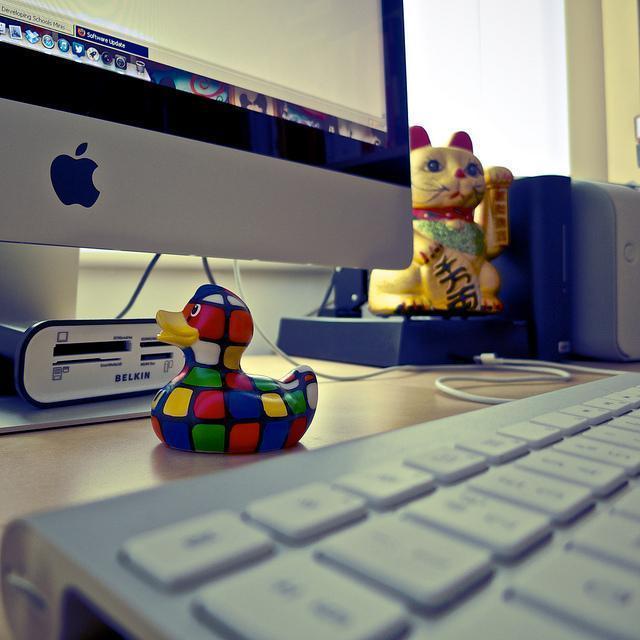How many people rowing are wearing bright green?
Give a very brief answer. 0. 